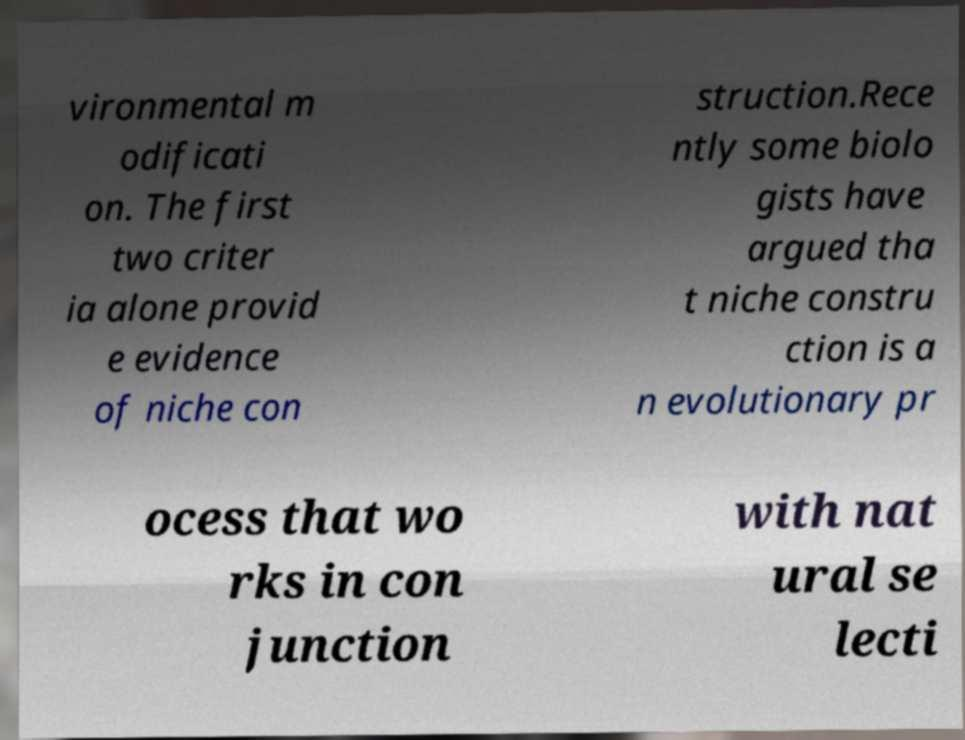There's text embedded in this image that I need extracted. Can you transcribe it verbatim? vironmental m odificati on. The first two criter ia alone provid e evidence of niche con struction.Rece ntly some biolo gists have argued tha t niche constru ction is a n evolutionary pr ocess that wo rks in con junction with nat ural se lecti 